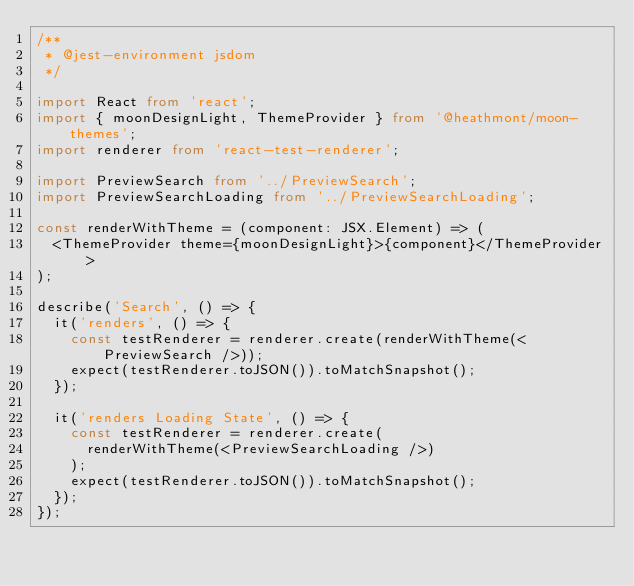<code> <loc_0><loc_0><loc_500><loc_500><_TypeScript_>/**
 * @jest-environment jsdom
 */

import React from 'react';
import { moonDesignLight, ThemeProvider } from '@heathmont/moon-themes';
import renderer from 'react-test-renderer';

import PreviewSearch from '../PreviewSearch';
import PreviewSearchLoading from '../PreviewSearchLoading';

const renderWithTheme = (component: JSX.Element) => (
  <ThemeProvider theme={moonDesignLight}>{component}</ThemeProvider>
);

describe('Search', () => {
  it('renders', () => {
    const testRenderer = renderer.create(renderWithTheme(<PreviewSearch />));
    expect(testRenderer.toJSON()).toMatchSnapshot();
  });

  it('renders Loading State', () => {
    const testRenderer = renderer.create(
      renderWithTheme(<PreviewSearchLoading />)
    );
    expect(testRenderer.toJSON()).toMatchSnapshot();
  });
});
</code> 